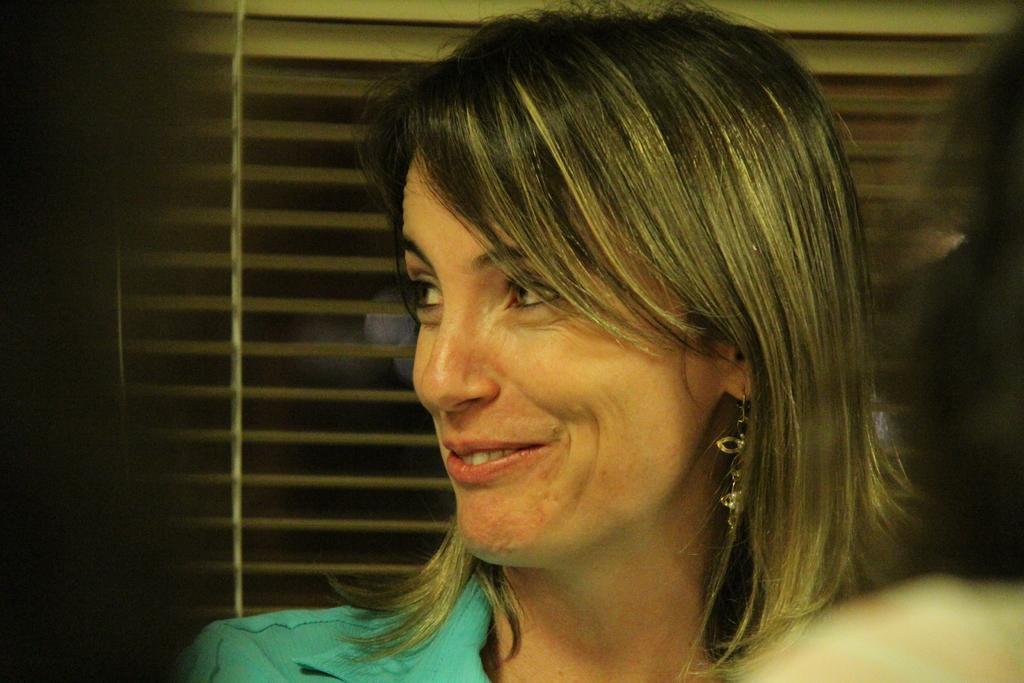Please provide a concise description of this image. A woman is smiling, she wore a green color dress behind her there is a window. 